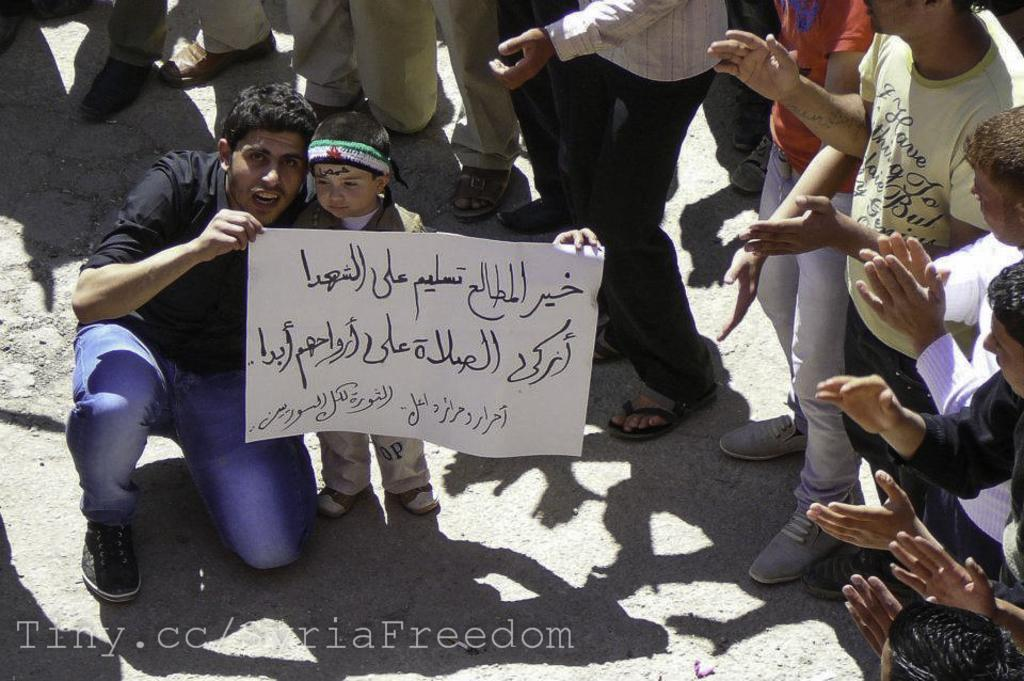What is the main subject of the image? The main subject of the image is a kid standing. What is the man in the image doing? The man is holding a paper in the image. How many people are standing in the image? There is a group of people standing in the image. Can you describe any additional features of the image? There is a watermark on the image. What type of tin can be seen in the image? There is no tin present in the image. Can you describe the yoke that the duck is wearing in the image? There is no duck or yoke present in the image. 